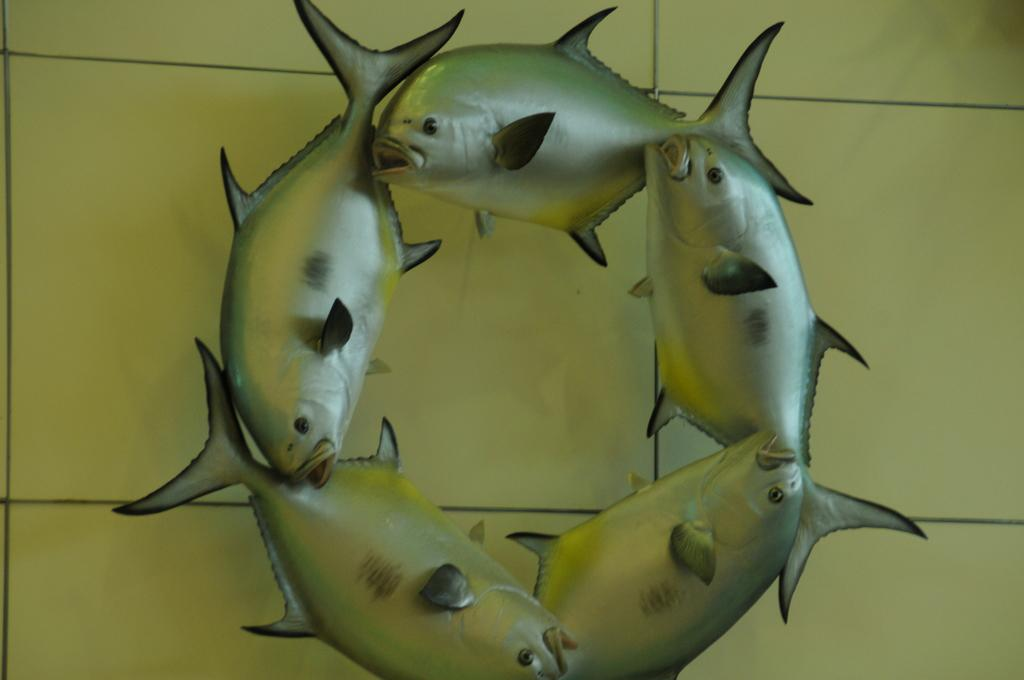What type of sculptures can be seen in the image? There are fish sculptures in the image. What is visible in the background of the image? There is a wall in the background of the image. What type of joke can be seen in the image? There is no joke present in the image; it features fish sculptures and a wall in the background. 